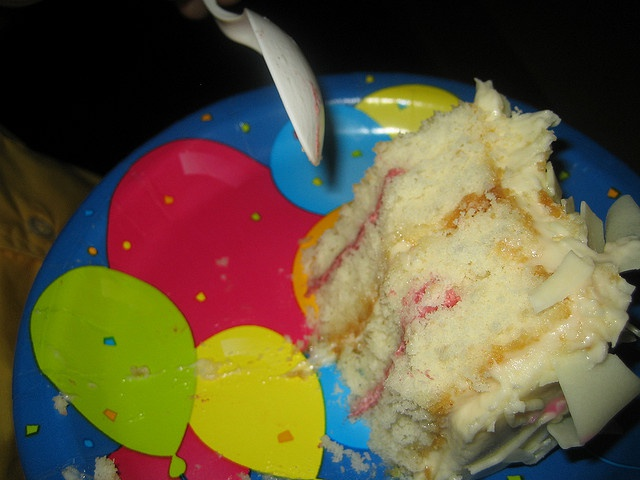Describe the objects in this image and their specific colors. I can see cake in black, tan, and khaki tones and spoon in black, darkgray, gray, and lightgray tones in this image. 